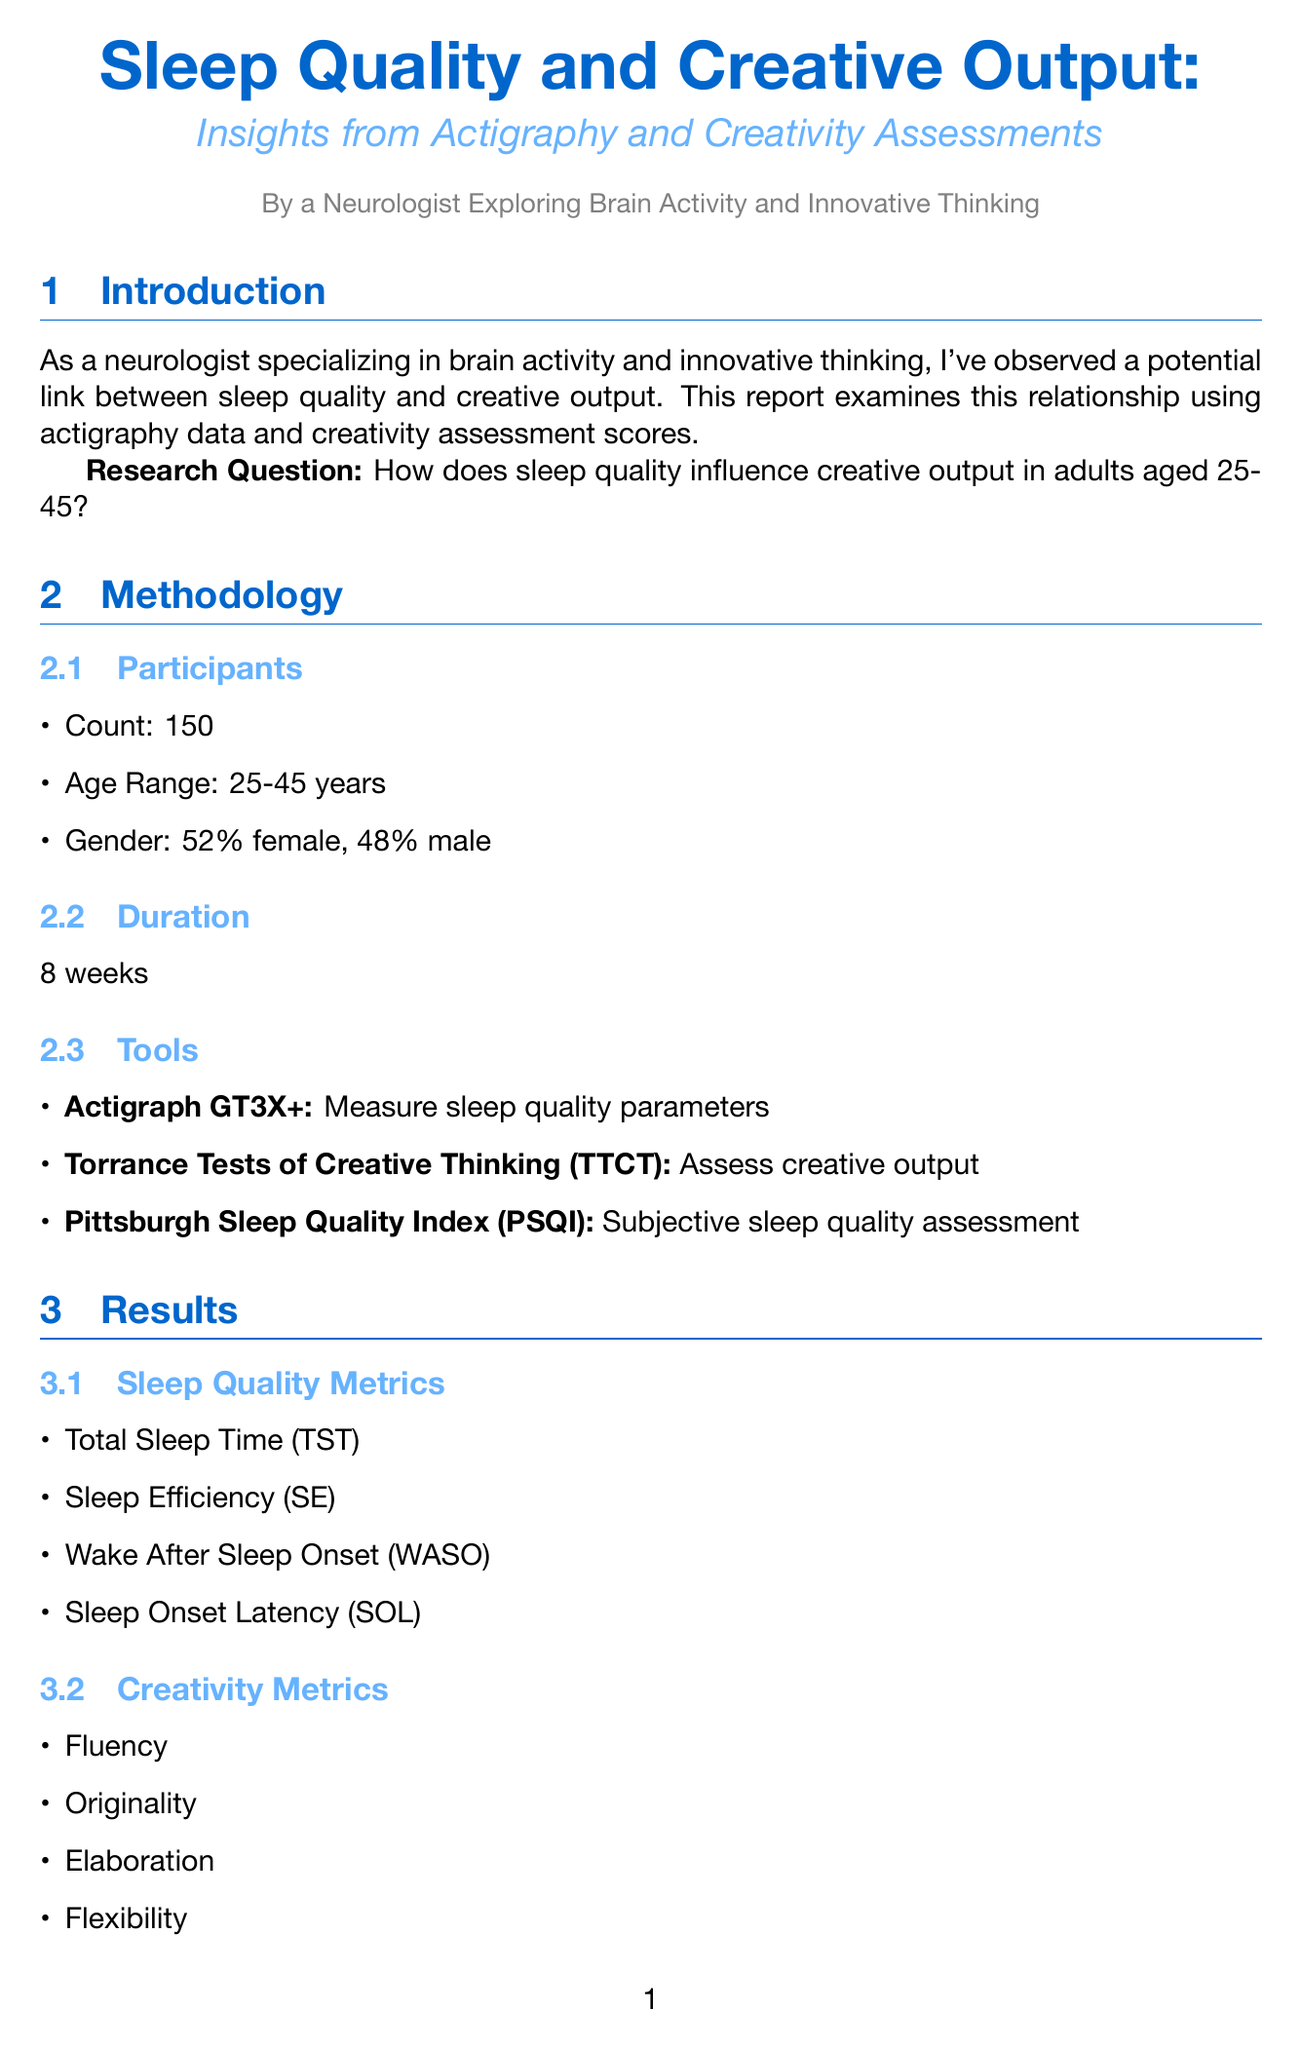What is the count of participants in the study? The study involved 150 participants, as stated in the methodology section.
Answer: 150 What is the age range of the participants? The participants' age range is specified in the document as 25-45 years.
Answer: 25-45 years What is the purpose of the Actigraph GT3X+? The purpose of the Actigraph GT3X+ is to measure sleep quality parameters, mentioned in the tools section.
Answer: Measure sleep quality parameters What is the correlation coefficient (r) between Sleep Efficiency and Originality scores? The document states a positive correlation of r = 0.68, providing a specific numerical relationship.
Answer: r = 0.68 What is one of the neurobiological mechanisms discussed in the report? The report mentions REM sleep and memory consolidation as a neurobiological mechanism.
Answer: REM sleep and memory consolidation What are the implications of this study mentioned in the discussion? The document discusses potential for sleep interventions to enhance creativity among other implications.
Answer: Potential for sleep interventions to enhance creativity What type of evidence does the study provide? The study provides compelling evidence for a significant relationship, as noted in the conclusion.
Answer: Compelling evidence What is one limitation of the study? The document states a lack of longitudinal data as one of the limitations.
Answer: Lack of longitudinal data What does the document suggest regarding sleep hygiene? It highlights the importance of sleep hygiene in creative professions as an implication.
Answer: Importance of sleep hygiene in creative professions 